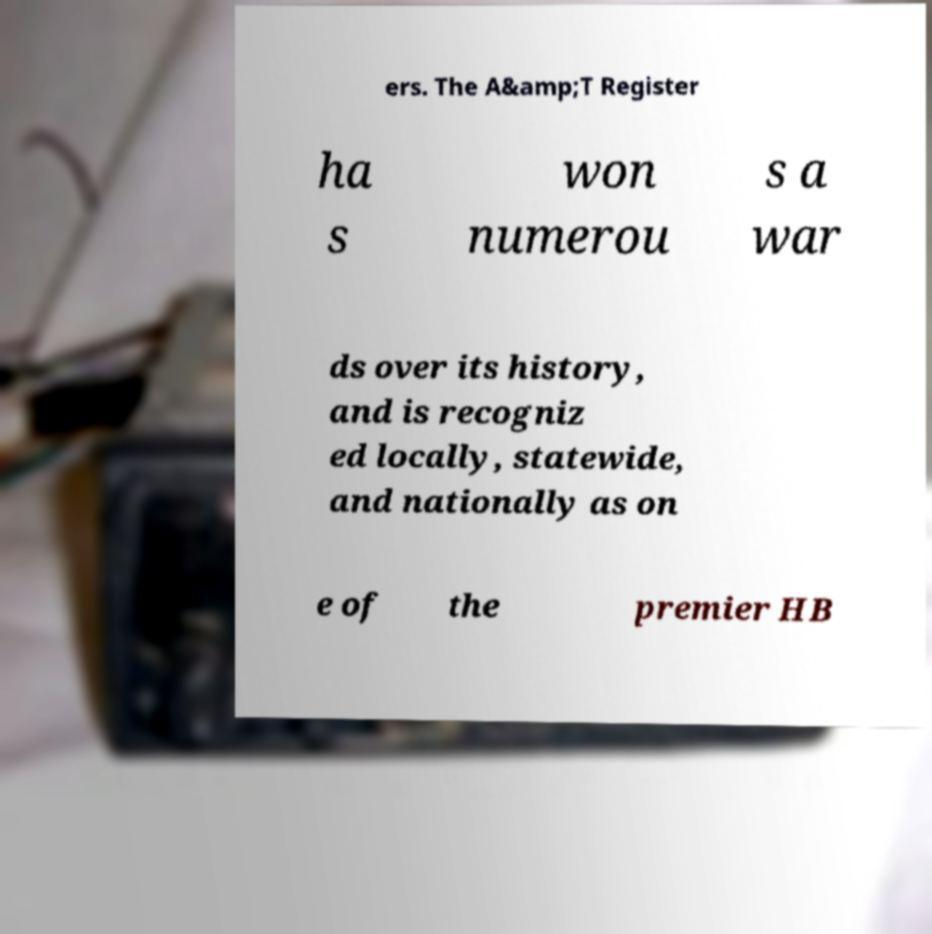Please read and relay the text visible in this image. What does it say? ers. The A&amp;T Register ha s won numerou s a war ds over its history, and is recogniz ed locally, statewide, and nationally as on e of the premier HB 